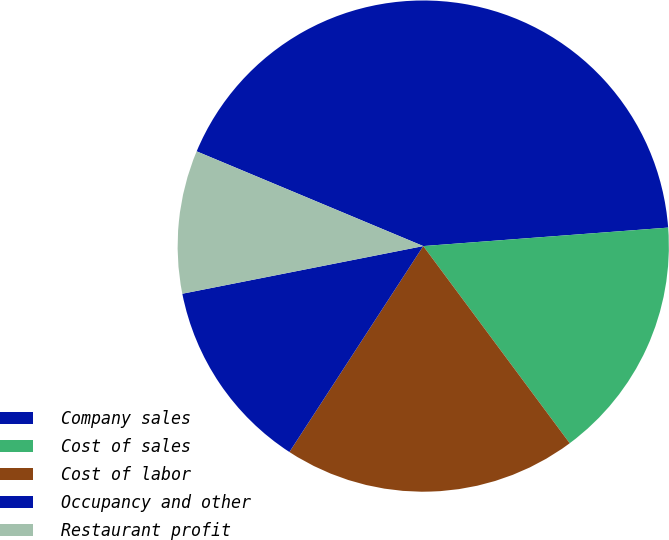Convert chart. <chart><loc_0><loc_0><loc_500><loc_500><pie_chart><fcel>Company sales<fcel>Cost of sales<fcel>Cost of labor<fcel>Occupancy and other<fcel>Restaurant profit<nl><fcel>42.5%<fcel>16.03%<fcel>19.34%<fcel>12.72%<fcel>9.41%<nl></chart> 